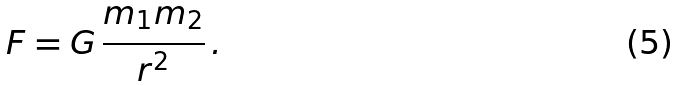<formula> <loc_0><loc_0><loc_500><loc_500>F = G \, \frac { m _ { 1 } m _ { 2 } } { r ^ { 2 } } \, .</formula> 